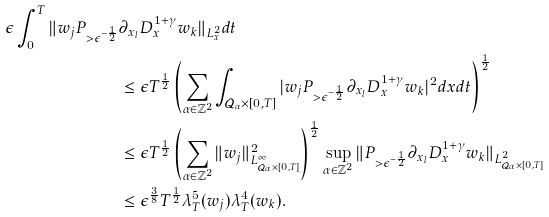<formula> <loc_0><loc_0><loc_500><loc_500>\epsilon \int _ { 0 } ^ { T } \| w _ { j } P _ { > \epsilon ^ { - \frac { 1 } { 2 } } } & \partial _ { x _ { l } } D _ { x } ^ { 1 + \gamma } w _ { k } \| _ { L ^ { 2 } _ { x } } d t \\ & \leq \epsilon T ^ { \frac { 1 } { 2 } } \left ( \sum _ { \alpha \in \mathbb { Z } ^ { 2 } } \int _ { \mathcal { Q } _ { \alpha } \times [ 0 , T ] } | w _ { j } P _ { > \epsilon ^ { - \frac { 1 } { 2 } } } \partial _ { x _ { l } } D _ { x } ^ { 1 + \gamma } w _ { k } | ^ { 2 } d x d t \right ) ^ { \frac { 1 } { 2 } } \\ & \leq \epsilon T ^ { \frac { 1 } { 2 } } \left ( \sum _ { \alpha \in \mathbb { Z } ^ { 2 } } \| w _ { j } \| _ { L ^ { \infty } _ { \mathcal { Q } _ { \alpha } \times [ 0 , T ] } } ^ { 2 } \right ) ^ { \frac { 1 } { 2 } } \sup _ { \alpha \in \mathbb { Z } ^ { 2 } } \| P _ { > \epsilon ^ { - \frac { 1 } { 2 } } } \partial _ { x _ { l } } D _ { x } ^ { 1 + \gamma } w _ { k } \| _ { L ^ { 2 } _ { \mathcal { Q } _ { \alpha } \times [ 0 , T ] } } \\ & \leq \epsilon ^ { \frac { 3 } { 8 } } T ^ { \frac { 1 } { 2 } } \lambda _ { T } ^ { 5 } ( w _ { j } ) \lambda _ { T } ^ { 4 } ( w _ { k } ) .</formula> 